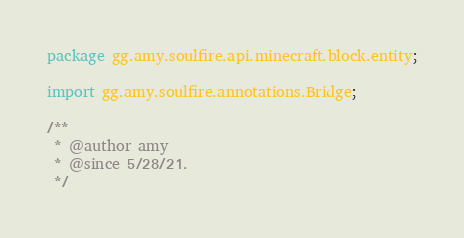Convert code to text. <code><loc_0><loc_0><loc_500><loc_500><_Java_>package gg.amy.soulfire.api.minecraft.block.entity;

import gg.amy.soulfire.annotations.Bridge;

/**
 * @author amy
 * @since 5/28/21.
 */</code> 